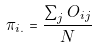<formula> <loc_0><loc_0><loc_500><loc_500>\pi _ { i . } = \frac { \sum _ { j } O _ { i j } } { N }</formula> 